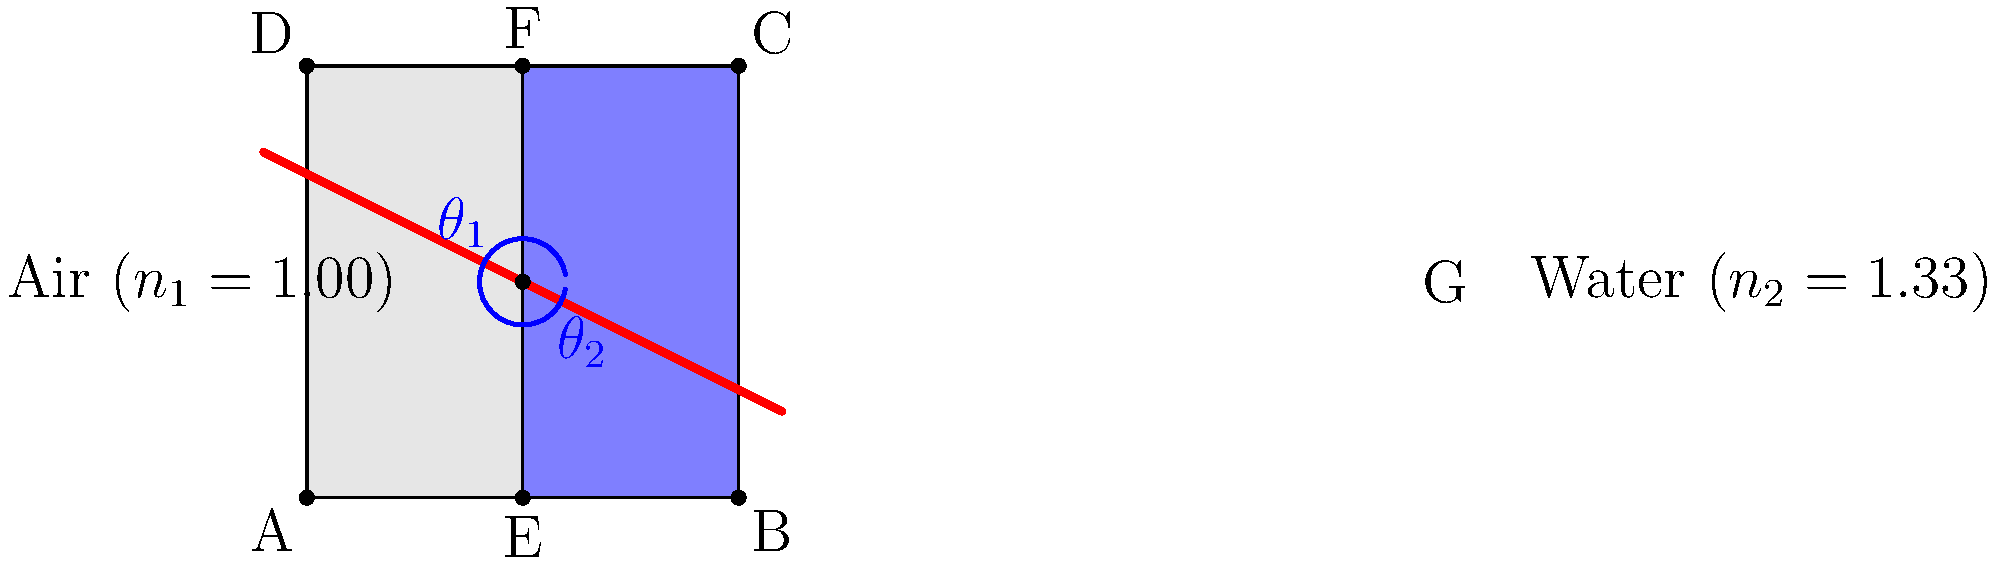A light ray travels from air into water, as shown in the diagram. If the angle of incidence ($\theta_1$) is 60°, what is the angle of refraction ($\theta_2$) in the water? Use Snell's law and round your answer to the nearest degree. To solve this problem, we'll use Snell's law and follow these steps:

1) Recall Snell's law: $n_1 \sin(\theta_1) = n_2 \sin(\theta_2)$

2) We're given:
   - $n_1 = 1.00$ (air)
   - $n_2 = 1.33$ (water)
   - $\theta_1 = 60°$

3) Substitute these values into Snell's law:
   $1.00 \sin(60°) = 1.33 \sin(\theta_2)$

4) Simplify the left side:
   $\sin(60°) = 0.866 = 1.33 \sin(\theta_2)$

5) Solve for $\sin(\theta_2)$:
   $\sin(\theta_2) = \frac{0.866}{1.33} = 0.651$

6) Take the inverse sine (arcsin) of both sides:
   $\theta_2 = \arcsin(0.651)$

7) Calculate and round to the nearest degree:
   $\theta_2 \approx 40°$

Thus, the angle of refraction in water is approximately 40°.
Answer: 40° 